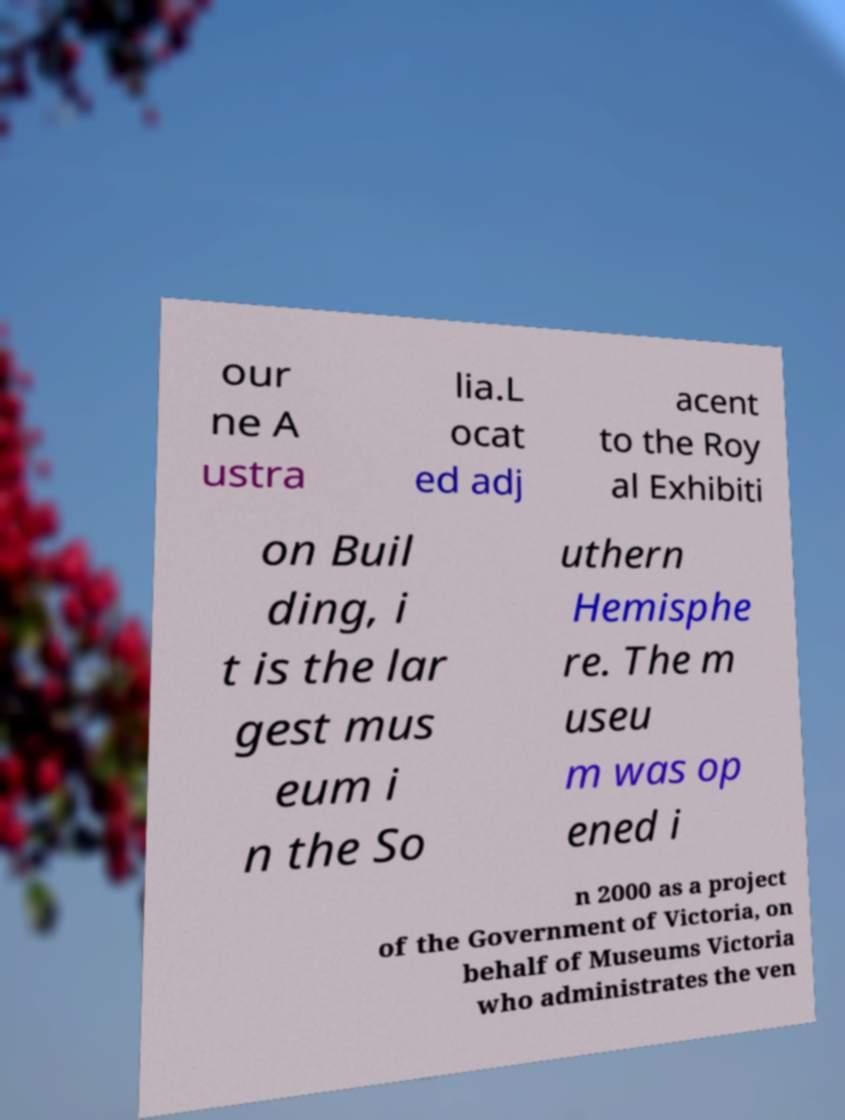Could you extract and type out the text from this image? our ne A ustra lia.L ocat ed adj acent to the Roy al Exhibiti on Buil ding, i t is the lar gest mus eum i n the So uthern Hemisphe re. The m useu m was op ened i n 2000 as a project of the Government of Victoria, on behalf of Museums Victoria who administrates the ven 